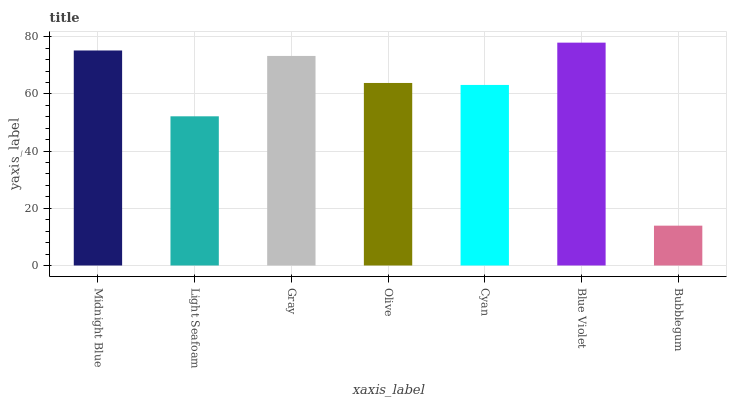Is Bubblegum the minimum?
Answer yes or no. Yes. Is Blue Violet the maximum?
Answer yes or no. Yes. Is Light Seafoam the minimum?
Answer yes or no. No. Is Light Seafoam the maximum?
Answer yes or no. No. Is Midnight Blue greater than Light Seafoam?
Answer yes or no. Yes. Is Light Seafoam less than Midnight Blue?
Answer yes or no. Yes. Is Light Seafoam greater than Midnight Blue?
Answer yes or no. No. Is Midnight Blue less than Light Seafoam?
Answer yes or no. No. Is Olive the high median?
Answer yes or no. Yes. Is Olive the low median?
Answer yes or no. Yes. Is Cyan the high median?
Answer yes or no. No. Is Bubblegum the low median?
Answer yes or no. No. 